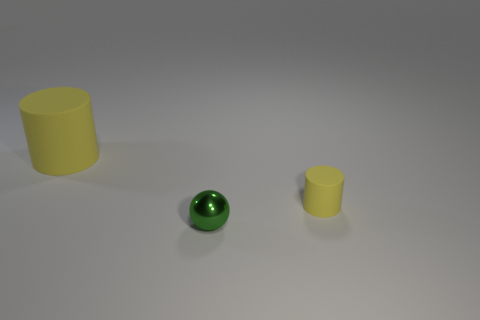Add 1 tiny green things. How many objects exist? 4 Add 1 small yellow rubber objects. How many small yellow rubber objects are left? 2 Add 3 large cylinders. How many large cylinders exist? 4 Subtract 0 purple spheres. How many objects are left? 3 Subtract all cylinders. How many objects are left? 1 Subtract all small purple matte cylinders. Subtract all big yellow objects. How many objects are left? 2 